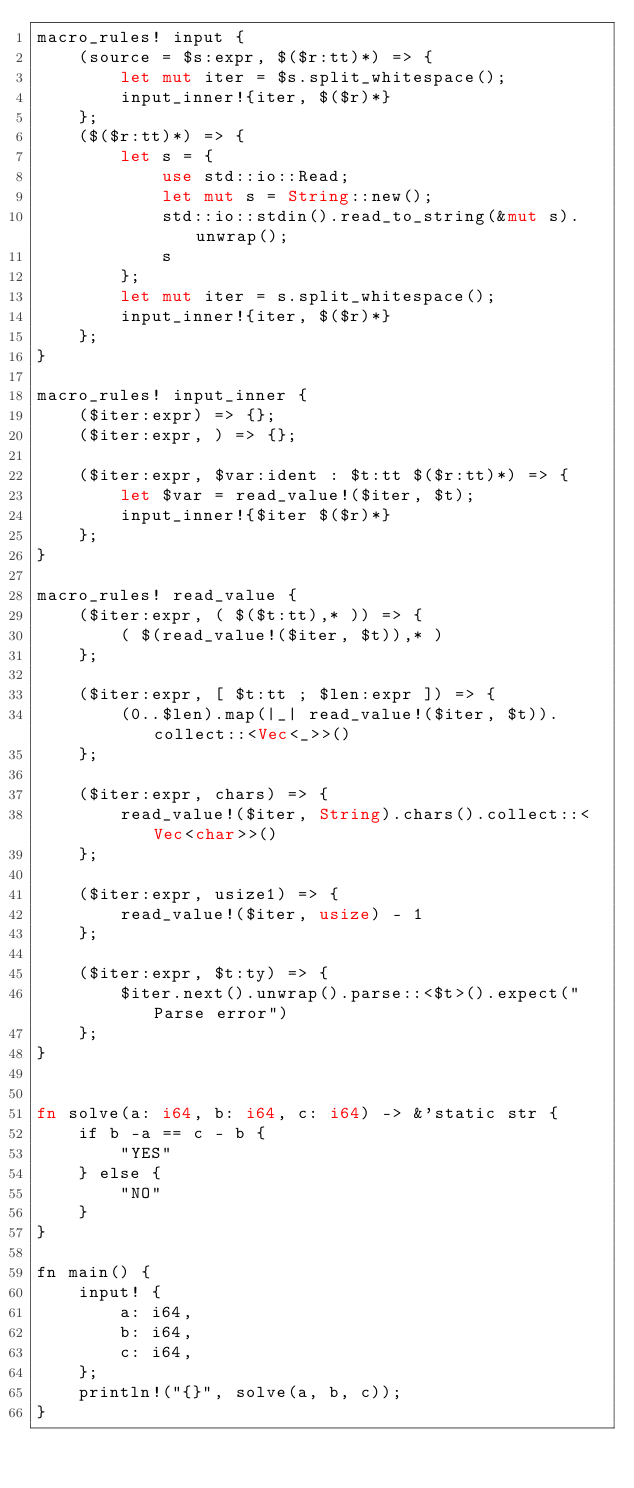Convert code to text. <code><loc_0><loc_0><loc_500><loc_500><_Rust_>macro_rules! input {
    (source = $s:expr, $($r:tt)*) => {
        let mut iter = $s.split_whitespace();
        input_inner!{iter, $($r)*}
    };
    ($($r:tt)*) => {
        let s = {
            use std::io::Read;
            let mut s = String::new();
            std::io::stdin().read_to_string(&mut s).unwrap();
            s
        };
        let mut iter = s.split_whitespace();
        input_inner!{iter, $($r)*}
    };
}

macro_rules! input_inner {
    ($iter:expr) => {};
    ($iter:expr, ) => {};

    ($iter:expr, $var:ident : $t:tt $($r:tt)*) => {
        let $var = read_value!($iter, $t);
        input_inner!{$iter $($r)*}
    };
}

macro_rules! read_value {
    ($iter:expr, ( $($t:tt),* )) => {
        ( $(read_value!($iter, $t)),* )
    };

    ($iter:expr, [ $t:tt ; $len:expr ]) => {
        (0..$len).map(|_| read_value!($iter, $t)).collect::<Vec<_>>()
    };

    ($iter:expr, chars) => {
        read_value!($iter, String).chars().collect::<Vec<char>>()
    };

    ($iter:expr, usize1) => {
        read_value!($iter, usize) - 1
    };

    ($iter:expr, $t:ty) => {
        $iter.next().unwrap().parse::<$t>().expect("Parse error")
    };
}


fn solve(a: i64, b: i64, c: i64) -> &'static str {
    if b -a == c - b {
        "YES"
    } else {
        "NO"
    }
}

fn main() {
    input! {
        a: i64,
        b: i64,
        c: i64,
    };
    println!("{}", solve(a, b, c));
}
</code> 